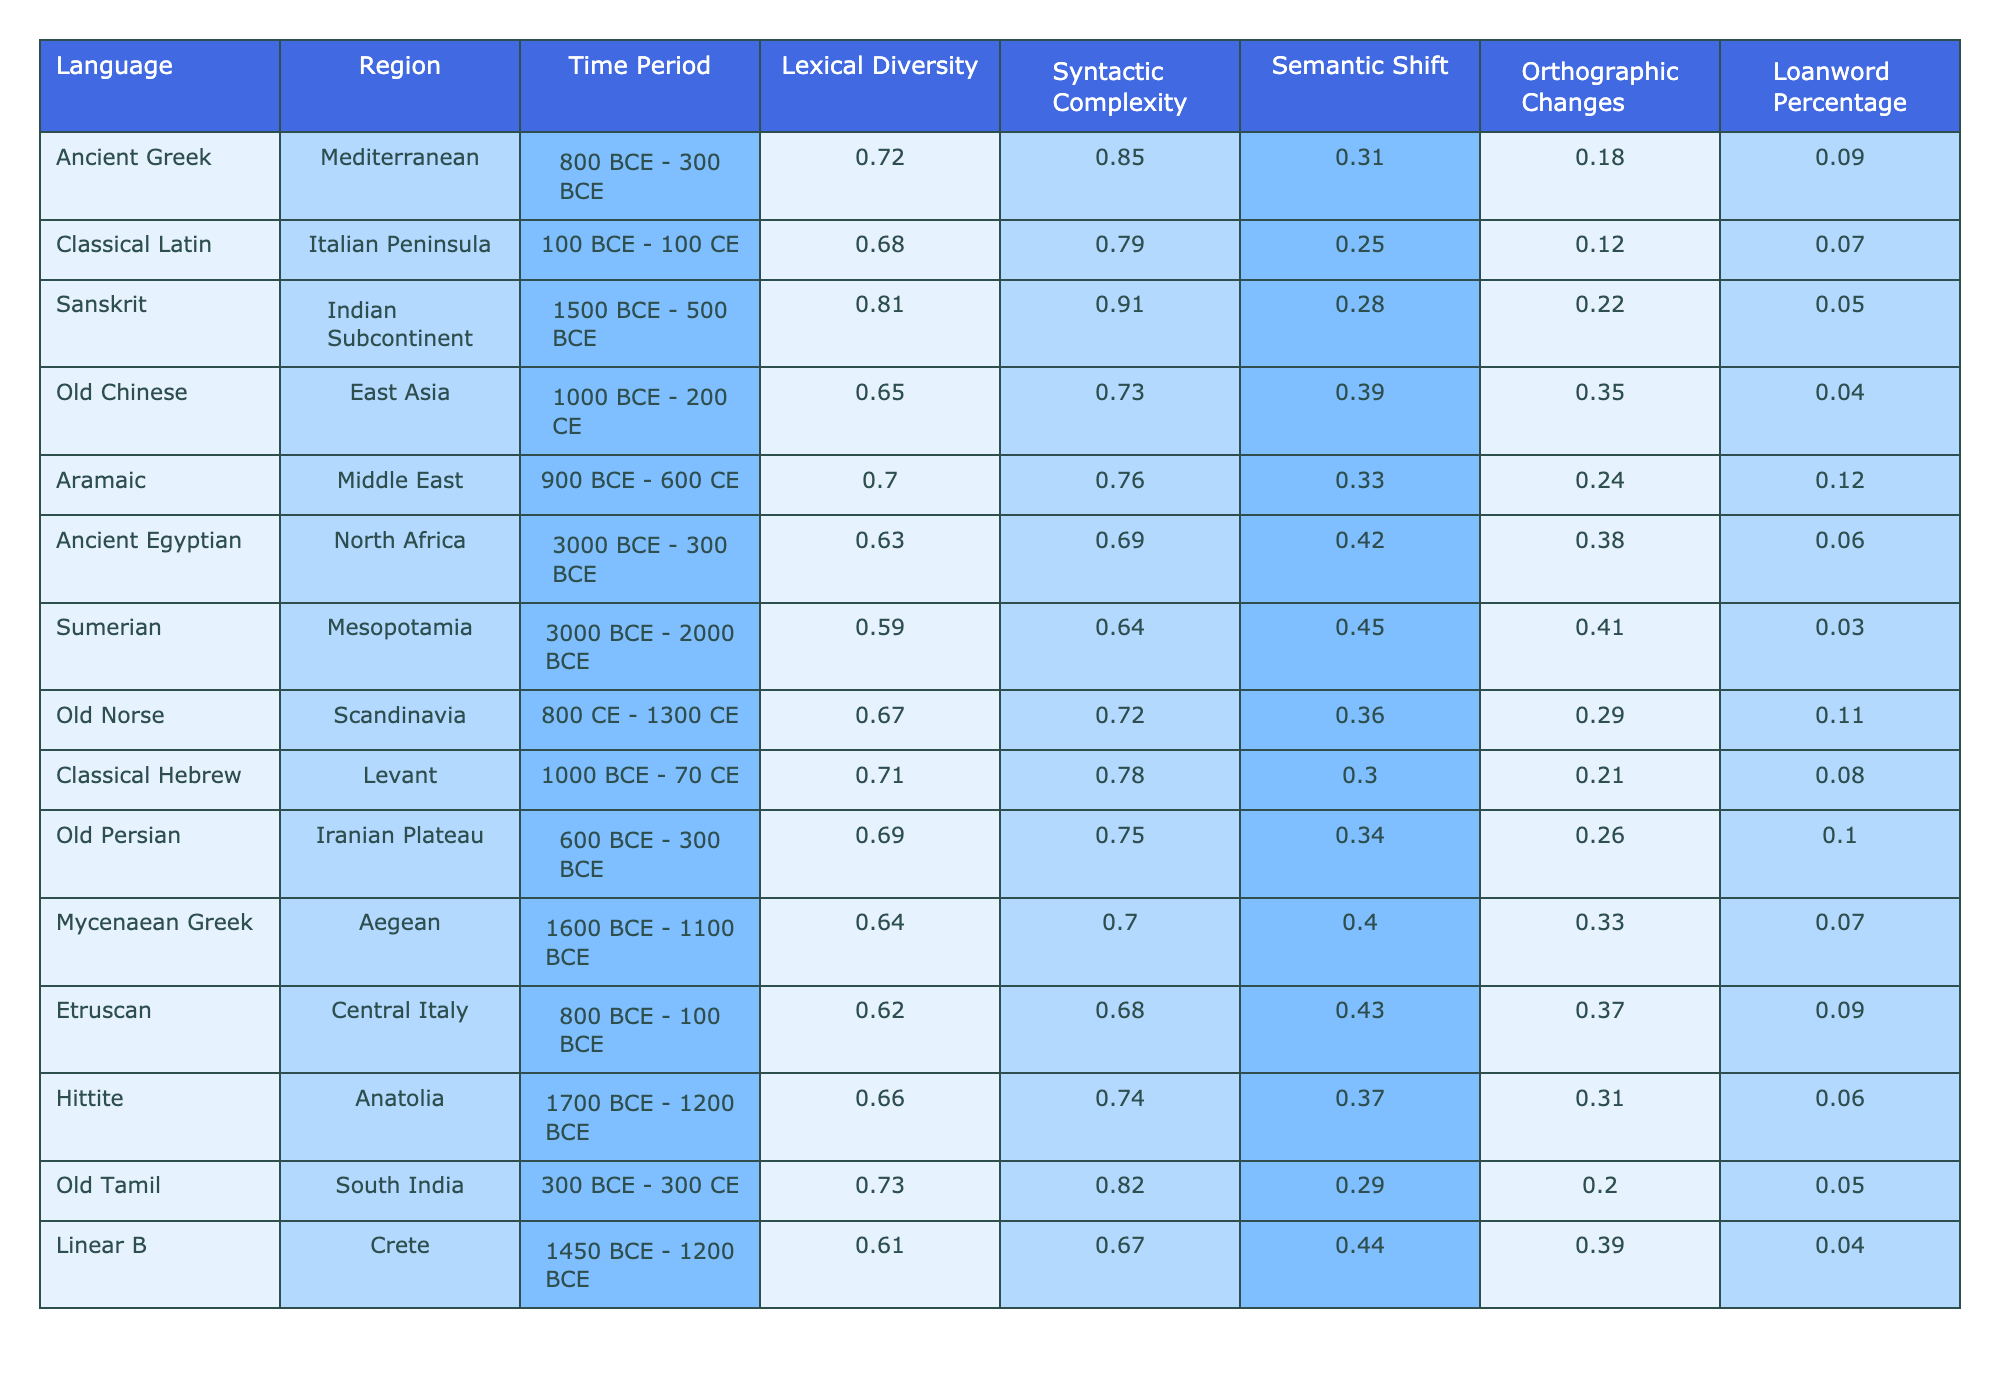What is the lexical diversity of Old Tamil? In the table, under the row for Old Tamil, the lexical diversity value is clearly indicated. The value is 0.73.
Answer: 0.73 Which language had the highest syntactic complexity? By reviewing the syntactic complexity values across all languages, we see that Sanskrit has the highest value at 0.91.
Answer: Sanskrit Is the loanword percentage for Ancient Egyptian greater than that of Sumerian? The loanword percentage for Ancient Egyptian is 0.06, while for Sumerian it is 0.03. Since 0.06 is greater than 0.03, the statement is true.
Answer: Yes What is the difference in semantic shift between Ancient Greek and Old Chinese? The semantic shift for Ancient Greek is 0.31 and for Old Chinese it is 0.39. To find the difference, we subtract 0.31 from 0.39, which gives us 0.08.
Answer: 0.08 Which region has the language with the lowest lexical diversity? By examining the lexical diversity values in the table, we find that Sumerian has the lowest value at 0.59, which corresponds to the Mesopotamia region.
Answer: Mesopotamia If we average the lexical diversity of the Mediterranean languages (Ancient Greek, Aramaic, and Mycenaean Greek), what would that be? The lexical diversity values for these languages are 0.72 (Ancient Greek), 0.70 (Aramaic), and 0.64 (Mycenaean Greek). Adding these values gives 0.72 + 0.70 + 0.64 = 2.06. Dividing by 3 gives us an average lexical diversity of 2.06/3 = 0.6867, which we can round to 0.69.
Answer: 0.69 Is there a notable orthographic change for Classical Latin compared to Classical Hebrew? The orthographic change for Classical Latin is 0.12 and for Classical Hebrew it is 0.21. Since 0.12 is less than 0.21, there is a notable difference in that Classical Hebrew has a greater orthographic change.
Answer: Yes What is the combined loanword percentage for the languages from the Iranian Plateau and the Middle East? The loanword percentage for Old Persian (Iranian Plateau) is 0.10, and for Aramaic (Middle East) it is 0.12. Adding these gives 0.10 + 0.12 = 0.22.
Answer: 0.22 Which language has a higher syntactic complexity, Old Norse or Etruscan? Checking the syntactic complexity values, Old Norse is 0.72 while Etruscan is 0.68. Since 0.72 is greater than 0.68, Old Norse has the higher syntactic complexity.
Answer: Old Norse What is the average loanword percentage for the languages spoken in the Aegean and Central Italy? The loanword percentage for Mycenaean Greek (Aegean) is 0.07 and for Etruscan (Central Italy) is 0.09. Adding these gives 0.07 + 0.09 = 0.16, and dividing by 2 gives us an average of 0.08.
Answer: 0.08 Does Old Chinese exhibit the highest semantic shift among the listed languages? The semantic shift for Old Chinese is 0.39, and the other languages have lower values. Thus, Old Chinese does exhibit the highest semantic shift.
Answer: Yes 